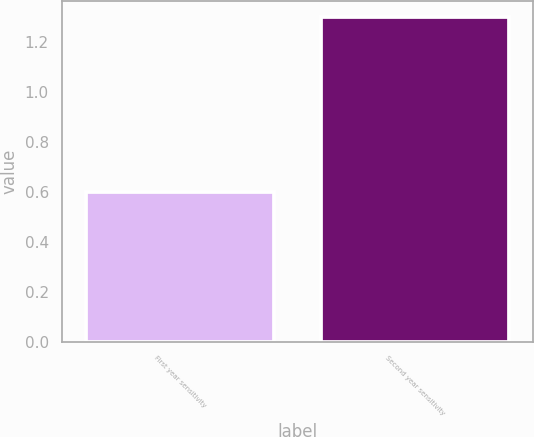<chart> <loc_0><loc_0><loc_500><loc_500><bar_chart><fcel>First year sensitivity<fcel>Second year sensitivity<nl><fcel>0.6<fcel>1.3<nl></chart> 